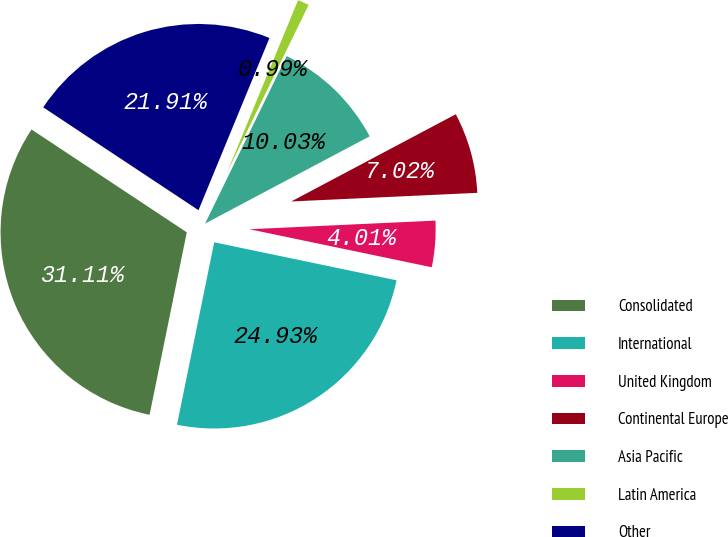Convert chart. <chart><loc_0><loc_0><loc_500><loc_500><pie_chart><fcel>Consolidated<fcel>International<fcel>United Kingdom<fcel>Continental Europe<fcel>Asia Pacific<fcel>Latin America<fcel>Other<nl><fcel>31.11%<fcel>24.93%<fcel>4.01%<fcel>7.02%<fcel>10.03%<fcel>0.99%<fcel>21.91%<nl></chart> 